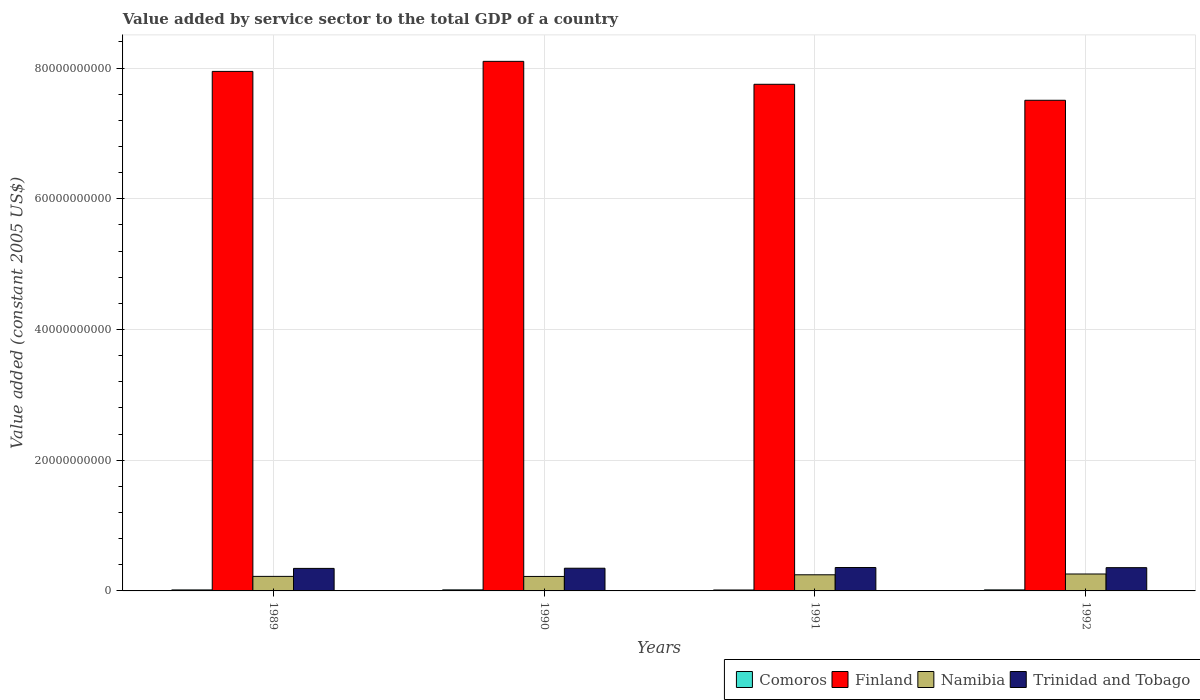How many different coloured bars are there?
Provide a succinct answer. 4. Are the number of bars on each tick of the X-axis equal?
Give a very brief answer. Yes. In how many cases, is the number of bars for a given year not equal to the number of legend labels?
Give a very brief answer. 0. What is the value added by service sector in Finland in 1991?
Give a very brief answer. 7.75e+1. Across all years, what is the maximum value added by service sector in Comoros?
Your answer should be compact. 1.59e+08. Across all years, what is the minimum value added by service sector in Trinidad and Tobago?
Provide a short and direct response. 3.45e+09. What is the total value added by service sector in Comoros in the graph?
Your response must be concise. 6.07e+08. What is the difference between the value added by service sector in Comoros in 1989 and that in 1992?
Make the answer very short. -5.08e+06. What is the difference between the value added by service sector in Trinidad and Tobago in 1992 and the value added by service sector in Comoros in 1991?
Give a very brief answer. 3.42e+09. What is the average value added by service sector in Comoros per year?
Offer a terse response. 1.52e+08. In the year 1990, what is the difference between the value added by service sector in Namibia and value added by service sector in Comoros?
Your answer should be very brief. 2.06e+09. In how many years, is the value added by service sector in Trinidad and Tobago greater than 64000000000 US$?
Offer a terse response. 0. What is the ratio of the value added by service sector in Trinidad and Tobago in 1990 to that in 1991?
Keep it short and to the point. 0.97. Is the value added by service sector in Trinidad and Tobago in 1989 less than that in 1991?
Your answer should be compact. Yes. Is the difference between the value added by service sector in Namibia in 1991 and 1992 greater than the difference between the value added by service sector in Comoros in 1991 and 1992?
Your answer should be very brief. No. What is the difference between the highest and the second highest value added by service sector in Namibia?
Ensure brevity in your answer.  1.21e+08. What is the difference between the highest and the lowest value added by service sector in Finland?
Ensure brevity in your answer.  5.95e+09. Is it the case that in every year, the sum of the value added by service sector in Finland and value added by service sector in Trinidad and Tobago is greater than the sum of value added by service sector in Namibia and value added by service sector in Comoros?
Provide a succinct answer. Yes. What does the 1st bar from the left in 1992 represents?
Provide a short and direct response. Comoros. What does the 2nd bar from the right in 1990 represents?
Provide a short and direct response. Namibia. How many years are there in the graph?
Your answer should be compact. 4. Where does the legend appear in the graph?
Offer a very short reply. Bottom right. How are the legend labels stacked?
Your answer should be compact. Horizontal. What is the title of the graph?
Give a very brief answer. Value added by service sector to the total GDP of a country. What is the label or title of the X-axis?
Provide a succinct answer. Years. What is the label or title of the Y-axis?
Provide a succinct answer. Value added (constant 2005 US$). What is the Value added (constant 2005 US$) in Comoros in 1989?
Keep it short and to the point. 1.51e+08. What is the Value added (constant 2005 US$) in Finland in 1989?
Give a very brief answer. 7.95e+1. What is the Value added (constant 2005 US$) in Namibia in 1989?
Provide a short and direct response. 2.23e+09. What is the Value added (constant 2005 US$) in Trinidad and Tobago in 1989?
Provide a succinct answer. 3.45e+09. What is the Value added (constant 2005 US$) in Comoros in 1990?
Ensure brevity in your answer.  1.59e+08. What is the Value added (constant 2005 US$) of Finland in 1990?
Your answer should be compact. 8.10e+1. What is the Value added (constant 2005 US$) of Namibia in 1990?
Your answer should be very brief. 2.21e+09. What is the Value added (constant 2005 US$) in Trinidad and Tobago in 1990?
Keep it short and to the point. 3.47e+09. What is the Value added (constant 2005 US$) in Comoros in 1991?
Provide a short and direct response. 1.42e+08. What is the Value added (constant 2005 US$) in Finland in 1991?
Provide a short and direct response. 7.75e+1. What is the Value added (constant 2005 US$) in Namibia in 1991?
Ensure brevity in your answer.  2.47e+09. What is the Value added (constant 2005 US$) in Trinidad and Tobago in 1991?
Provide a succinct answer. 3.58e+09. What is the Value added (constant 2005 US$) in Comoros in 1992?
Keep it short and to the point. 1.56e+08. What is the Value added (constant 2005 US$) of Finland in 1992?
Offer a terse response. 7.51e+1. What is the Value added (constant 2005 US$) of Namibia in 1992?
Offer a terse response. 2.59e+09. What is the Value added (constant 2005 US$) of Trinidad and Tobago in 1992?
Provide a short and direct response. 3.56e+09. Across all years, what is the maximum Value added (constant 2005 US$) of Comoros?
Offer a very short reply. 1.59e+08. Across all years, what is the maximum Value added (constant 2005 US$) in Finland?
Keep it short and to the point. 8.10e+1. Across all years, what is the maximum Value added (constant 2005 US$) of Namibia?
Offer a very short reply. 2.59e+09. Across all years, what is the maximum Value added (constant 2005 US$) in Trinidad and Tobago?
Your answer should be very brief. 3.58e+09. Across all years, what is the minimum Value added (constant 2005 US$) in Comoros?
Provide a succinct answer. 1.42e+08. Across all years, what is the minimum Value added (constant 2005 US$) in Finland?
Ensure brevity in your answer.  7.51e+1. Across all years, what is the minimum Value added (constant 2005 US$) in Namibia?
Offer a very short reply. 2.21e+09. Across all years, what is the minimum Value added (constant 2005 US$) of Trinidad and Tobago?
Your answer should be compact. 3.45e+09. What is the total Value added (constant 2005 US$) of Comoros in the graph?
Offer a terse response. 6.07e+08. What is the total Value added (constant 2005 US$) of Finland in the graph?
Give a very brief answer. 3.13e+11. What is the total Value added (constant 2005 US$) in Namibia in the graph?
Give a very brief answer. 9.50e+09. What is the total Value added (constant 2005 US$) in Trinidad and Tobago in the graph?
Provide a short and direct response. 1.41e+1. What is the difference between the Value added (constant 2005 US$) of Comoros in 1989 and that in 1990?
Your answer should be compact. -8.01e+06. What is the difference between the Value added (constant 2005 US$) of Finland in 1989 and that in 1990?
Make the answer very short. -1.54e+09. What is the difference between the Value added (constant 2005 US$) in Namibia in 1989 and that in 1990?
Give a very brief answer. 1.13e+07. What is the difference between the Value added (constant 2005 US$) of Trinidad and Tobago in 1989 and that in 1990?
Your answer should be compact. -2.78e+07. What is the difference between the Value added (constant 2005 US$) of Comoros in 1989 and that in 1991?
Ensure brevity in your answer.  8.69e+06. What is the difference between the Value added (constant 2005 US$) in Finland in 1989 and that in 1991?
Make the answer very short. 1.97e+09. What is the difference between the Value added (constant 2005 US$) of Namibia in 1989 and that in 1991?
Give a very brief answer. -2.44e+08. What is the difference between the Value added (constant 2005 US$) of Trinidad and Tobago in 1989 and that in 1991?
Ensure brevity in your answer.  -1.35e+08. What is the difference between the Value added (constant 2005 US$) in Comoros in 1989 and that in 1992?
Offer a very short reply. -5.08e+06. What is the difference between the Value added (constant 2005 US$) in Finland in 1989 and that in 1992?
Make the answer very short. 4.42e+09. What is the difference between the Value added (constant 2005 US$) in Namibia in 1989 and that in 1992?
Your answer should be compact. -3.65e+08. What is the difference between the Value added (constant 2005 US$) in Trinidad and Tobago in 1989 and that in 1992?
Your answer should be compact. -1.14e+08. What is the difference between the Value added (constant 2005 US$) of Comoros in 1990 and that in 1991?
Your response must be concise. 1.67e+07. What is the difference between the Value added (constant 2005 US$) of Finland in 1990 and that in 1991?
Your answer should be very brief. 3.51e+09. What is the difference between the Value added (constant 2005 US$) in Namibia in 1990 and that in 1991?
Provide a succinct answer. -2.55e+08. What is the difference between the Value added (constant 2005 US$) of Trinidad and Tobago in 1990 and that in 1991?
Offer a very short reply. -1.07e+08. What is the difference between the Value added (constant 2005 US$) in Comoros in 1990 and that in 1992?
Give a very brief answer. 2.93e+06. What is the difference between the Value added (constant 2005 US$) of Finland in 1990 and that in 1992?
Give a very brief answer. 5.95e+09. What is the difference between the Value added (constant 2005 US$) in Namibia in 1990 and that in 1992?
Your response must be concise. -3.76e+08. What is the difference between the Value added (constant 2005 US$) in Trinidad and Tobago in 1990 and that in 1992?
Your response must be concise. -8.63e+07. What is the difference between the Value added (constant 2005 US$) in Comoros in 1991 and that in 1992?
Your response must be concise. -1.38e+07. What is the difference between the Value added (constant 2005 US$) in Finland in 1991 and that in 1992?
Keep it short and to the point. 2.45e+09. What is the difference between the Value added (constant 2005 US$) in Namibia in 1991 and that in 1992?
Your response must be concise. -1.21e+08. What is the difference between the Value added (constant 2005 US$) of Trinidad and Tobago in 1991 and that in 1992?
Give a very brief answer. 2.06e+07. What is the difference between the Value added (constant 2005 US$) in Comoros in 1989 and the Value added (constant 2005 US$) in Finland in 1990?
Your response must be concise. -8.09e+1. What is the difference between the Value added (constant 2005 US$) of Comoros in 1989 and the Value added (constant 2005 US$) of Namibia in 1990?
Keep it short and to the point. -2.06e+09. What is the difference between the Value added (constant 2005 US$) of Comoros in 1989 and the Value added (constant 2005 US$) of Trinidad and Tobago in 1990?
Keep it short and to the point. -3.32e+09. What is the difference between the Value added (constant 2005 US$) in Finland in 1989 and the Value added (constant 2005 US$) in Namibia in 1990?
Provide a short and direct response. 7.73e+1. What is the difference between the Value added (constant 2005 US$) of Finland in 1989 and the Value added (constant 2005 US$) of Trinidad and Tobago in 1990?
Offer a very short reply. 7.60e+1. What is the difference between the Value added (constant 2005 US$) of Namibia in 1989 and the Value added (constant 2005 US$) of Trinidad and Tobago in 1990?
Your response must be concise. -1.25e+09. What is the difference between the Value added (constant 2005 US$) in Comoros in 1989 and the Value added (constant 2005 US$) in Finland in 1991?
Keep it short and to the point. -7.74e+1. What is the difference between the Value added (constant 2005 US$) in Comoros in 1989 and the Value added (constant 2005 US$) in Namibia in 1991?
Your response must be concise. -2.32e+09. What is the difference between the Value added (constant 2005 US$) of Comoros in 1989 and the Value added (constant 2005 US$) of Trinidad and Tobago in 1991?
Your response must be concise. -3.43e+09. What is the difference between the Value added (constant 2005 US$) of Finland in 1989 and the Value added (constant 2005 US$) of Namibia in 1991?
Your answer should be compact. 7.70e+1. What is the difference between the Value added (constant 2005 US$) in Finland in 1989 and the Value added (constant 2005 US$) in Trinidad and Tobago in 1991?
Your answer should be compact. 7.59e+1. What is the difference between the Value added (constant 2005 US$) of Namibia in 1989 and the Value added (constant 2005 US$) of Trinidad and Tobago in 1991?
Provide a short and direct response. -1.35e+09. What is the difference between the Value added (constant 2005 US$) in Comoros in 1989 and the Value added (constant 2005 US$) in Finland in 1992?
Provide a succinct answer. -7.49e+1. What is the difference between the Value added (constant 2005 US$) of Comoros in 1989 and the Value added (constant 2005 US$) of Namibia in 1992?
Offer a very short reply. -2.44e+09. What is the difference between the Value added (constant 2005 US$) in Comoros in 1989 and the Value added (constant 2005 US$) in Trinidad and Tobago in 1992?
Keep it short and to the point. -3.41e+09. What is the difference between the Value added (constant 2005 US$) of Finland in 1989 and the Value added (constant 2005 US$) of Namibia in 1992?
Provide a succinct answer. 7.69e+1. What is the difference between the Value added (constant 2005 US$) of Finland in 1989 and the Value added (constant 2005 US$) of Trinidad and Tobago in 1992?
Give a very brief answer. 7.59e+1. What is the difference between the Value added (constant 2005 US$) of Namibia in 1989 and the Value added (constant 2005 US$) of Trinidad and Tobago in 1992?
Offer a very short reply. -1.33e+09. What is the difference between the Value added (constant 2005 US$) in Comoros in 1990 and the Value added (constant 2005 US$) in Finland in 1991?
Your answer should be compact. -7.74e+1. What is the difference between the Value added (constant 2005 US$) in Comoros in 1990 and the Value added (constant 2005 US$) in Namibia in 1991?
Ensure brevity in your answer.  -2.31e+09. What is the difference between the Value added (constant 2005 US$) in Comoros in 1990 and the Value added (constant 2005 US$) in Trinidad and Tobago in 1991?
Your answer should be compact. -3.42e+09. What is the difference between the Value added (constant 2005 US$) of Finland in 1990 and the Value added (constant 2005 US$) of Namibia in 1991?
Provide a succinct answer. 7.86e+1. What is the difference between the Value added (constant 2005 US$) of Finland in 1990 and the Value added (constant 2005 US$) of Trinidad and Tobago in 1991?
Offer a very short reply. 7.75e+1. What is the difference between the Value added (constant 2005 US$) of Namibia in 1990 and the Value added (constant 2005 US$) of Trinidad and Tobago in 1991?
Keep it short and to the point. -1.37e+09. What is the difference between the Value added (constant 2005 US$) in Comoros in 1990 and the Value added (constant 2005 US$) in Finland in 1992?
Offer a very short reply. -7.49e+1. What is the difference between the Value added (constant 2005 US$) of Comoros in 1990 and the Value added (constant 2005 US$) of Namibia in 1992?
Offer a very short reply. -2.43e+09. What is the difference between the Value added (constant 2005 US$) in Comoros in 1990 and the Value added (constant 2005 US$) in Trinidad and Tobago in 1992?
Make the answer very short. -3.40e+09. What is the difference between the Value added (constant 2005 US$) of Finland in 1990 and the Value added (constant 2005 US$) of Namibia in 1992?
Make the answer very short. 7.84e+1. What is the difference between the Value added (constant 2005 US$) of Finland in 1990 and the Value added (constant 2005 US$) of Trinidad and Tobago in 1992?
Offer a very short reply. 7.75e+1. What is the difference between the Value added (constant 2005 US$) in Namibia in 1990 and the Value added (constant 2005 US$) in Trinidad and Tobago in 1992?
Your answer should be compact. -1.35e+09. What is the difference between the Value added (constant 2005 US$) in Comoros in 1991 and the Value added (constant 2005 US$) in Finland in 1992?
Make the answer very short. -7.49e+1. What is the difference between the Value added (constant 2005 US$) of Comoros in 1991 and the Value added (constant 2005 US$) of Namibia in 1992?
Provide a succinct answer. -2.45e+09. What is the difference between the Value added (constant 2005 US$) of Comoros in 1991 and the Value added (constant 2005 US$) of Trinidad and Tobago in 1992?
Your response must be concise. -3.42e+09. What is the difference between the Value added (constant 2005 US$) of Finland in 1991 and the Value added (constant 2005 US$) of Namibia in 1992?
Your answer should be compact. 7.49e+1. What is the difference between the Value added (constant 2005 US$) in Finland in 1991 and the Value added (constant 2005 US$) in Trinidad and Tobago in 1992?
Make the answer very short. 7.40e+1. What is the difference between the Value added (constant 2005 US$) in Namibia in 1991 and the Value added (constant 2005 US$) in Trinidad and Tobago in 1992?
Give a very brief answer. -1.09e+09. What is the average Value added (constant 2005 US$) of Comoros per year?
Provide a succinct answer. 1.52e+08. What is the average Value added (constant 2005 US$) of Finland per year?
Ensure brevity in your answer.  7.83e+1. What is the average Value added (constant 2005 US$) of Namibia per year?
Your answer should be very brief. 2.37e+09. What is the average Value added (constant 2005 US$) in Trinidad and Tobago per year?
Provide a short and direct response. 3.51e+09. In the year 1989, what is the difference between the Value added (constant 2005 US$) of Comoros and Value added (constant 2005 US$) of Finland?
Your answer should be very brief. -7.93e+1. In the year 1989, what is the difference between the Value added (constant 2005 US$) in Comoros and Value added (constant 2005 US$) in Namibia?
Make the answer very short. -2.07e+09. In the year 1989, what is the difference between the Value added (constant 2005 US$) of Comoros and Value added (constant 2005 US$) of Trinidad and Tobago?
Your answer should be compact. -3.30e+09. In the year 1989, what is the difference between the Value added (constant 2005 US$) of Finland and Value added (constant 2005 US$) of Namibia?
Your answer should be very brief. 7.73e+1. In the year 1989, what is the difference between the Value added (constant 2005 US$) in Finland and Value added (constant 2005 US$) in Trinidad and Tobago?
Provide a short and direct response. 7.61e+1. In the year 1989, what is the difference between the Value added (constant 2005 US$) of Namibia and Value added (constant 2005 US$) of Trinidad and Tobago?
Keep it short and to the point. -1.22e+09. In the year 1990, what is the difference between the Value added (constant 2005 US$) of Comoros and Value added (constant 2005 US$) of Finland?
Offer a very short reply. -8.09e+1. In the year 1990, what is the difference between the Value added (constant 2005 US$) in Comoros and Value added (constant 2005 US$) in Namibia?
Your answer should be compact. -2.06e+09. In the year 1990, what is the difference between the Value added (constant 2005 US$) in Comoros and Value added (constant 2005 US$) in Trinidad and Tobago?
Give a very brief answer. -3.31e+09. In the year 1990, what is the difference between the Value added (constant 2005 US$) in Finland and Value added (constant 2005 US$) in Namibia?
Offer a very short reply. 7.88e+1. In the year 1990, what is the difference between the Value added (constant 2005 US$) of Finland and Value added (constant 2005 US$) of Trinidad and Tobago?
Your answer should be very brief. 7.76e+1. In the year 1990, what is the difference between the Value added (constant 2005 US$) of Namibia and Value added (constant 2005 US$) of Trinidad and Tobago?
Offer a terse response. -1.26e+09. In the year 1991, what is the difference between the Value added (constant 2005 US$) in Comoros and Value added (constant 2005 US$) in Finland?
Keep it short and to the point. -7.74e+1. In the year 1991, what is the difference between the Value added (constant 2005 US$) in Comoros and Value added (constant 2005 US$) in Namibia?
Offer a terse response. -2.33e+09. In the year 1991, what is the difference between the Value added (constant 2005 US$) in Comoros and Value added (constant 2005 US$) in Trinidad and Tobago?
Offer a terse response. -3.44e+09. In the year 1991, what is the difference between the Value added (constant 2005 US$) in Finland and Value added (constant 2005 US$) in Namibia?
Offer a very short reply. 7.51e+1. In the year 1991, what is the difference between the Value added (constant 2005 US$) in Finland and Value added (constant 2005 US$) in Trinidad and Tobago?
Offer a very short reply. 7.39e+1. In the year 1991, what is the difference between the Value added (constant 2005 US$) in Namibia and Value added (constant 2005 US$) in Trinidad and Tobago?
Make the answer very short. -1.11e+09. In the year 1992, what is the difference between the Value added (constant 2005 US$) of Comoros and Value added (constant 2005 US$) of Finland?
Ensure brevity in your answer.  -7.49e+1. In the year 1992, what is the difference between the Value added (constant 2005 US$) in Comoros and Value added (constant 2005 US$) in Namibia?
Your response must be concise. -2.43e+09. In the year 1992, what is the difference between the Value added (constant 2005 US$) in Comoros and Value added (constant 2005 US$) in Trinidad and Tobago?
Offer a very short reply. -3.40e+09. In the year 1992, what is the difference between the Value added (constant 2005 US$) in Finland and Value added (constant 2005 US$) in Namibia?
Offer a very short reply. 7.25e+1. In the year 1992, what is the difference between the Value added (constant 2005 US$) in Finland and Value added (constant 2005 US$) in Trinidad and Tobago?
Make the answer very short. 7.15e+1. In the year 1992, what is the difference between the Value added (constant 2005 US$) of Namibia and Value added (constant 2005 US$) of Trinidad and Tobago?
Your answer should be very brief. -9.69e+08. What is the ratio of the Value added (constant 2005 US$) in Comoros in 1989 to that in 1990?
Keep it short and to the point. 0.95. What is the ratio of the Value added (constant 2005 US$) in Finland in 1989 to that in 1990?
Offer a terse response. 0.98. What is the ratio of the Value added (constant 2005 US$) in Namibia in 1989 to that in 1990?
Make the answer very short. 1.01. What is the ratio of the Value added (constant 2005 US$) in Comoros in 1989 to that in 1991?
Your answer should be very brief. 1.06. What is the ratio of the Value added (constant 2005 US$) of Finland in 1989 to that in 1991?
Give a very brief answer. 1.03. What is the ratio of the Value added (constant 2005 US$) in Namibia in 1989 to that in 1991?
Offer a very short reply. 0.9. What is the ratio of the Value added (constant 2005 US$) in Trinidad and Tobago in 1989 to that in 1991?
Provide a short and direct response. 0.96. What is the ratio of the Value added (constant 2005 US$) of Comoros in 1989 to that in 1992?
Your response must be concise. 0.97. What is the ratio of the Value added (constant 2005 US$) of Finland in 1989 to that in 1992?
Keep it short and to the point. 1.06. What is the ratio of the Value added (constant 2005 US$) of Namibia in 1989 to that in 1992?
Ensure brevity in your answer.  0.86. What is the ratio of the Value added (constant 2005 US$) of Comoros in 1990 to that in 1991?
Your answer should be compact. 1.12. What is the ratio of the Value added (constant 2005 US$) of Finland in 1990 to that in 1991?
Offer a very short reply. 1.05. What is the ratio of the Value added (constant 2005 US$) of Namibia in 1990 to that in 1991?
Ensure brevity in your answer.  0.9. What is the ratio of the Value added (constant 2005 US$) of Trinidad and Tobago in 1990 to that in 1991?
Provide a succinct answer. 0.97. What is the ratio of the Value added (constant 2005 US$) in Comoros in 1990 to that in 1992?
Offer a terse response. 1.02. What is the ratio of the Value added (constant 2005 US$) in Finland in 1990 to that in 1992?
Give a very brief answer. 1.08. What is the ratio of the Value added (constant 2005 US$) of Namibia in 1990 to that in 1992?
Offer a very short reply. 0.85. What is the ratio of the Value added (constant 2005 US$) in Trinidad and Tobago in 1990 to that in 1992?
Your response must be concise. 0.98. What is the ratio of the Value added (constant 2005 US$) of Comoros in 1991 to that in 1992?
Offer a very short reply. 0.91. What is the ratio of the Value added (constant 2005 US$) of Finland in 1991 to that in 1992?
Your answer should be compact. 1.03. What is the ratio of the Value added (constant 2005 US$) in Namibia in 1991 to that in 1992?
Provide a short and direct response. 0.95. What is the difference between the highest and the second highest Value added (constant 2005 US$) of Comoros?
Ensure brevity in your answer.  2.93e+06. What is the difference between the highest and the second highest Value added (constant 2005 US$) of Finland?
Your response must be concise. 1.54e+09. What is the difference between the highest and the second highest Value added (constant 2005 US$) of Namibia?
Provide a short and direct response. 1.21e+08. What is the difference between the highest and the second highest Value added (constant 2005 US$) in Trinidad and Tobago?
Keep it short and to the point. 2.06e+07. What is the difference between the highest and the lowest Value added (constant 2005 US$) of Comoros?
Ensure brevity in your answer.  1.67e+07. What is the difference between the highest and the lowest Value added (constant 2005 US$) in Finland?
Offer a very short reply. 5.95e+09. What is the difference between the highest and the lowest Value added (constant 2005 US$) in Namibia?
Provide a short and direct response. 3.76e+08. What is the difference between the highest and the lowest Value added (constant 2005 US$) in Trinidad and Tobago?
Offer a very short reply. 1.35e+08. 